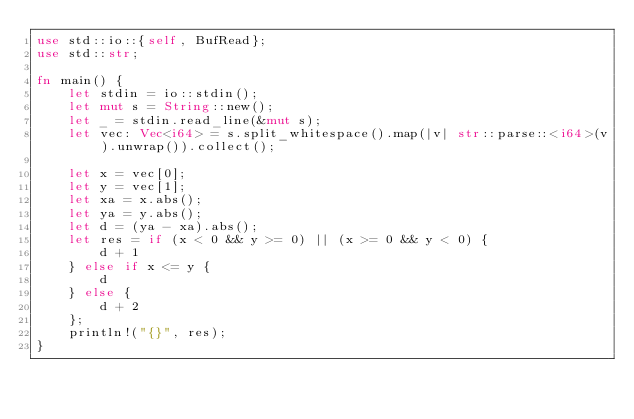<code> <loc_0><loc_0><loc_500><loc_500><_Rust_>use std::io::{self, BufRead};
use std::str;

fn main() {
    let stdin = io::stdin();
    let mut s = String::new();
    let _ = stdin.read_line(&mut s);
    let vec: Vec<i64> = s.split_whitespace().map(|v| str::parse::<i64>(v).unwrap()).collect();

    let x = vec[0];
    let y = vec[1];
    let xa = x.abs();
    let ya = y.abs();
    let d = (ya - xa).abs();
    let res = if (x < 0 && y >= 0) || (x >= 0 && y < 0) {
        d + 1
    } else if x <= y {
        d
    } else {
        d + 2
    };
    println!("{}", res);
}
</code> 